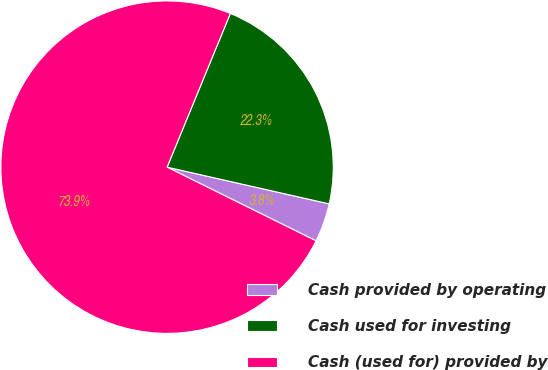<chart> <loc_0><loc_0><loc_500><loc_500><pie_chart><fcel>Cash provided by operating<fcel>Cash used for investing<fcel>Cash (used for) provided by<nl><fcel>3.77%<fcel>22.33%<fcel>73.9%<nl></chart> 